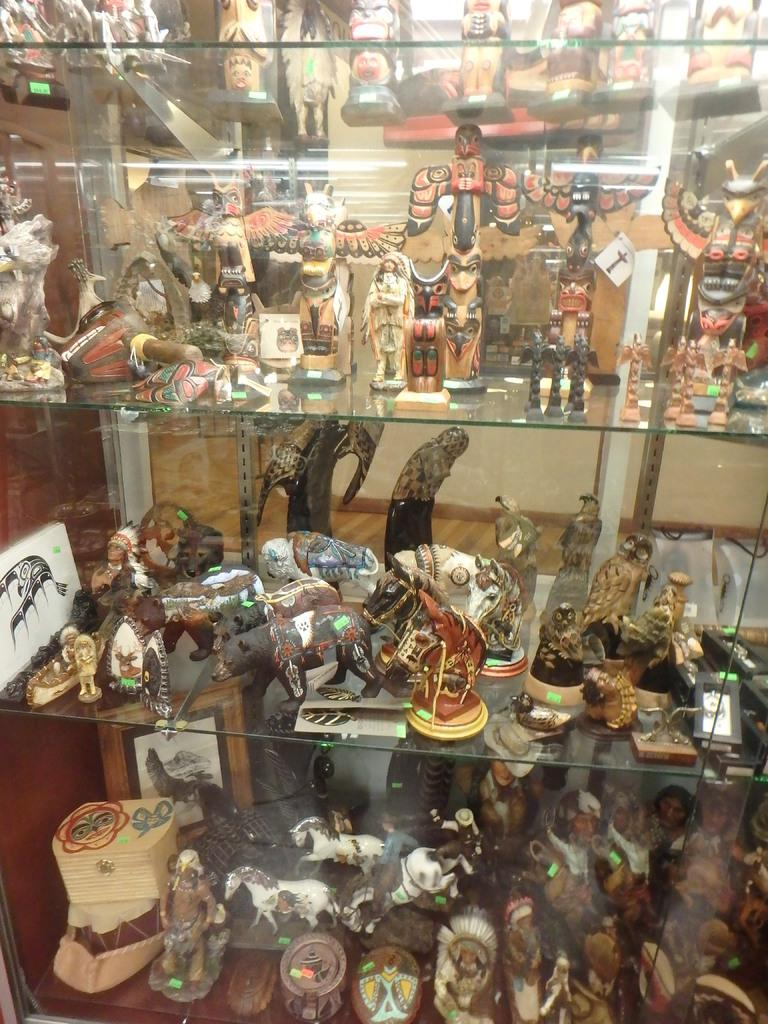What types of idols are present in the shelves in the image? There are animal idols, person idols, and bird idols in the shelves. Can you describe the wall behind the shelves? There is a wall behind the shelves in the image. What type of weather can be seen in the image? There is no indication of weather in the image, as it features idols in shelves and a wall behind them. What discovery was made while examining the idols in the image? There is no mention of a discovery being made in the image, as it simply shows idols in shelves and a wall behind them. 